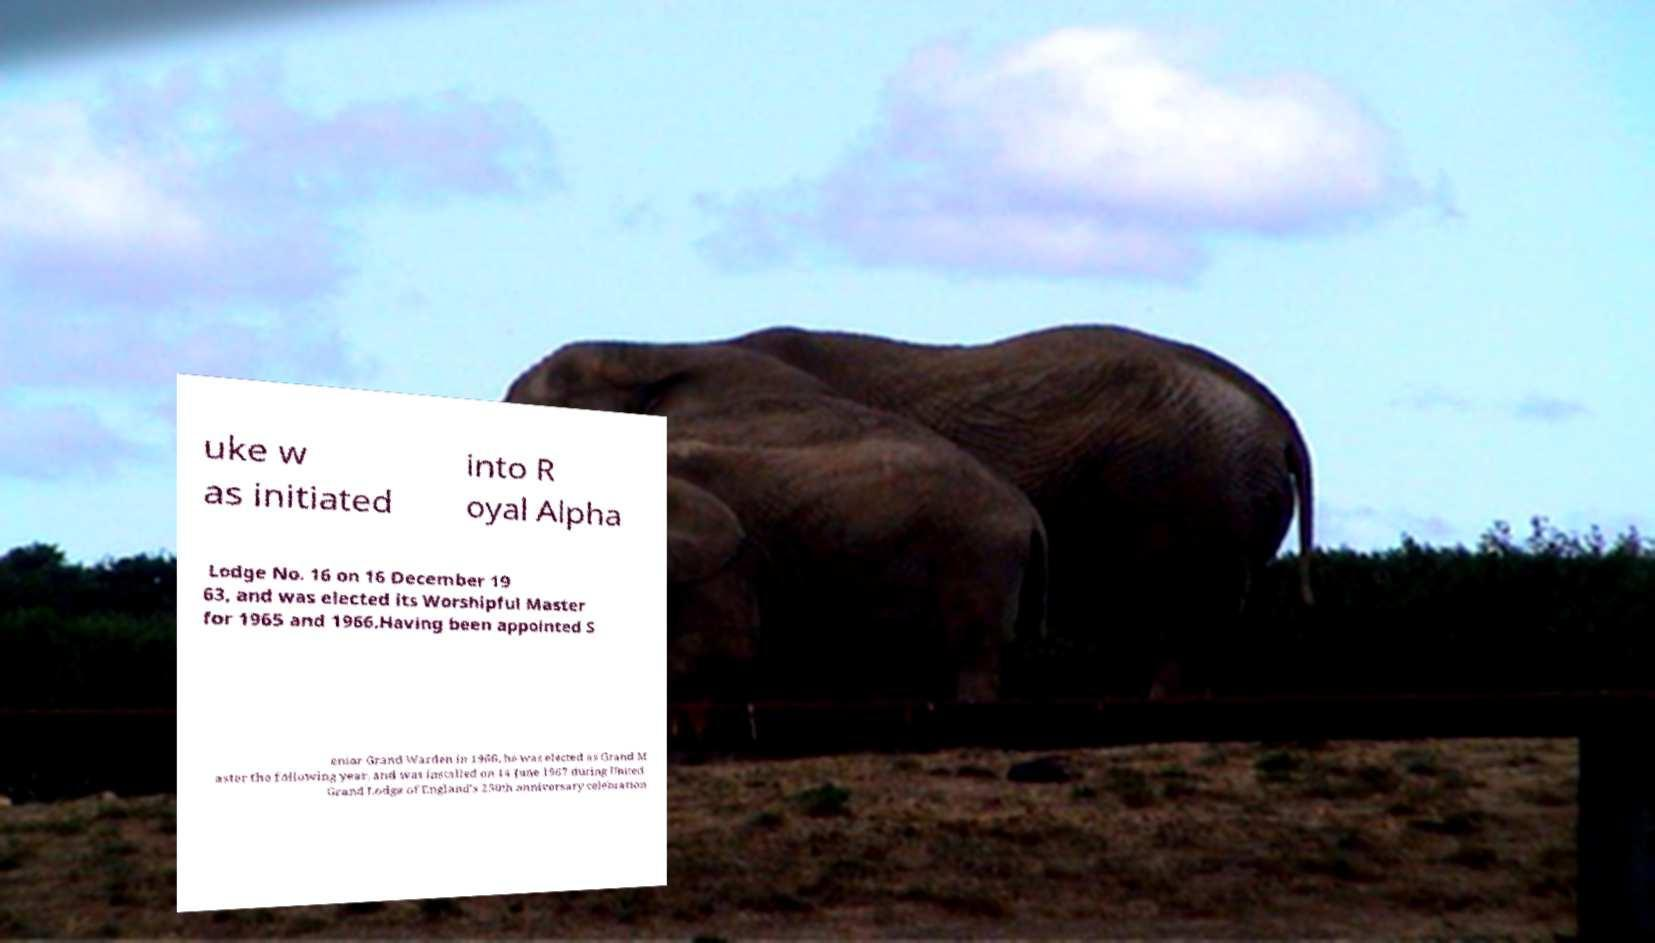What messages or text are displayed in this image? I need them in a readable, typed format. uke w as initiated into R oyal Alpha Lodge No. 16 on 16 December 19 63, and was elected its Worshipful Master for 1965 and 1966.Having been appointed S enior Grand Warden in 1966, he was elected as Grand M aster the following year, and was installed on 14 June 1967 during United Grand Lodge of England's 250th anniversary celebration 